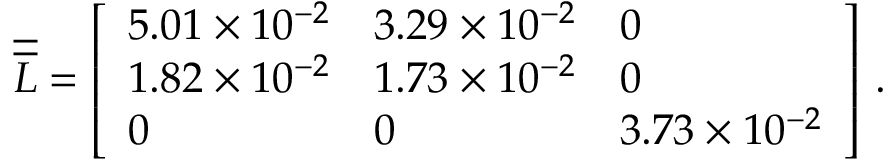Convert formula to latex. <formula><loc_0><loc_0><loc_500><loc_500>\overline { { \overline { L } } } = \left [ \begin{array} { l l l } { 5 . 0 1 \times 1 0 ^ { - 2 } } & { 3 . 2 9 \times 1 0 ^ { - 2 } } & { 0 } \\ { 1 . 8 2 \times 1 0 ^ { - 2 } } & { 1 . 7 3 \times 1 0 ^ { - 2 } } & { 0 } \\ { 0 } & { 0 } & { 3 . 7 3 \times 1 0 ^ { - 2 } } \end{array} \right ] \, .</formula> 